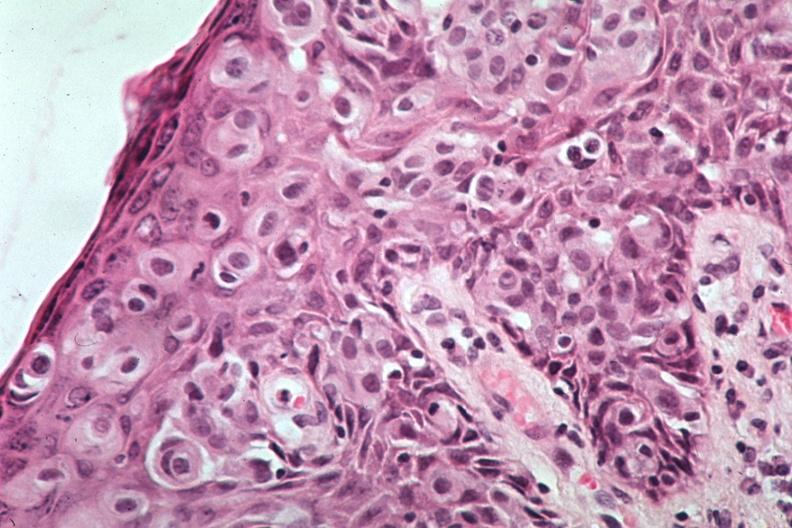how is this image a quite example of pagets disease?
Answer the question using a single word or phrase. Excellent 